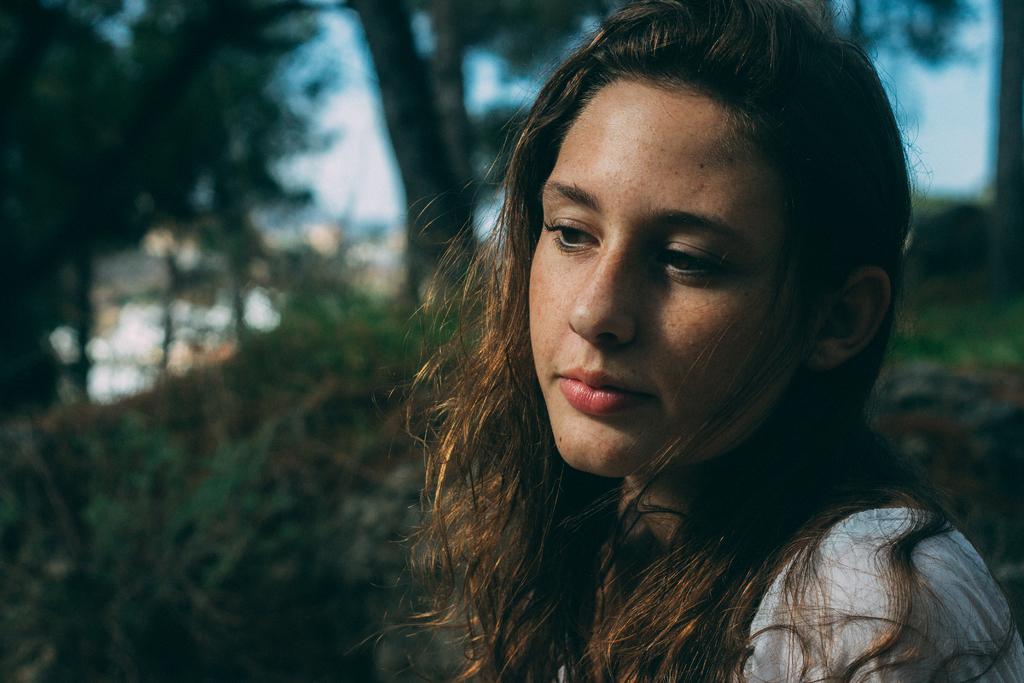Could you give a brief overview of what you see in this image? In the foreground of the picture there is a woman. In the background there are trees. 